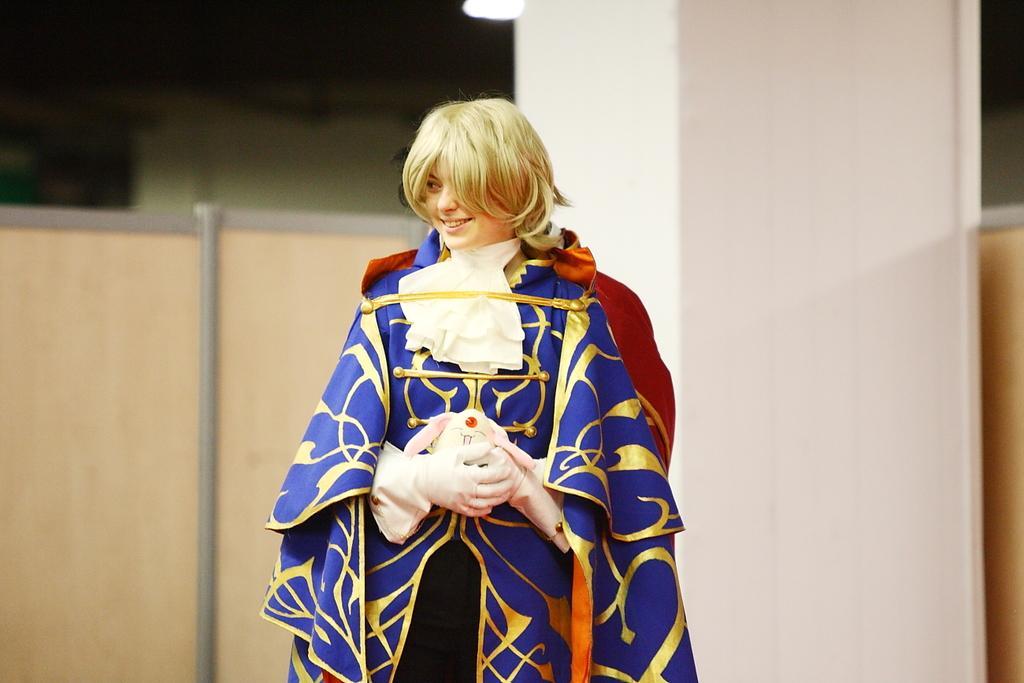How would you summarize this image in a sentence or two? This image is taken indoors. In the background there is a wall and there is a pillar and there is a wooden cabin. At the top of the image there is a light. In the middle of the image a woman is standing and she is with a smiling face. She is holding a toy in her hands. 